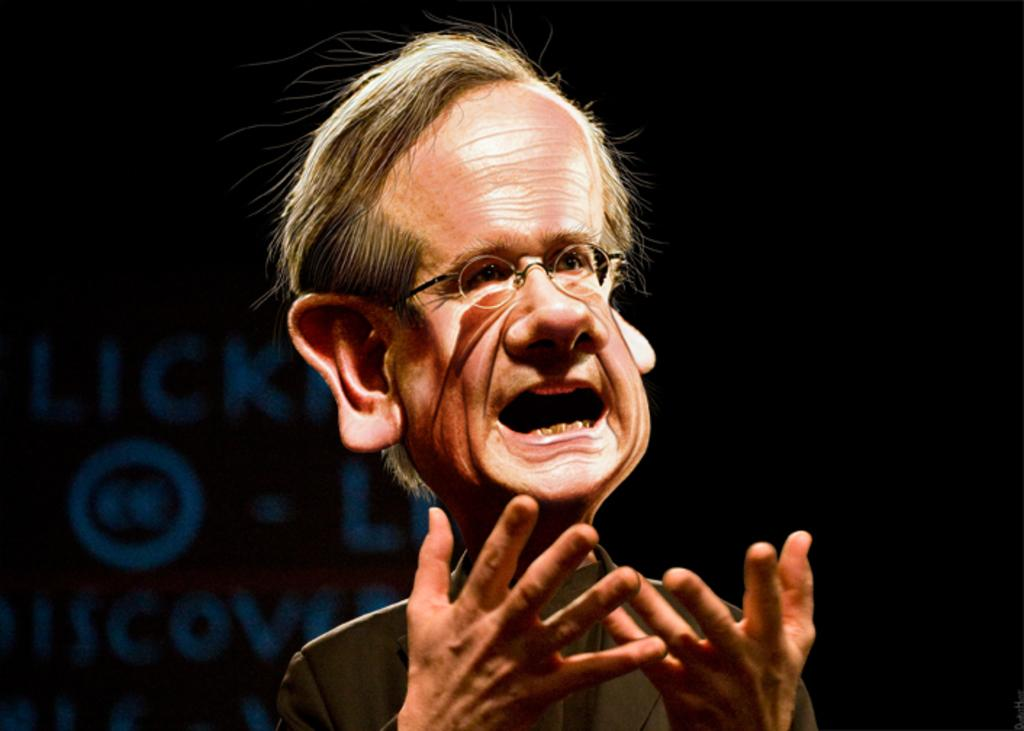What is the main subject of the image? There is a person's face in the image. What else can be seen in the background of the image? There is text in the background of the image. How would you describe the overall appearance of the image? The background of the image is dark. How many cattle are present in the image? There are no cattle present in the image. What scientific discovery is being made in the image? There is no scientific discovery being made in the image; it features a person's face and text in the background. 